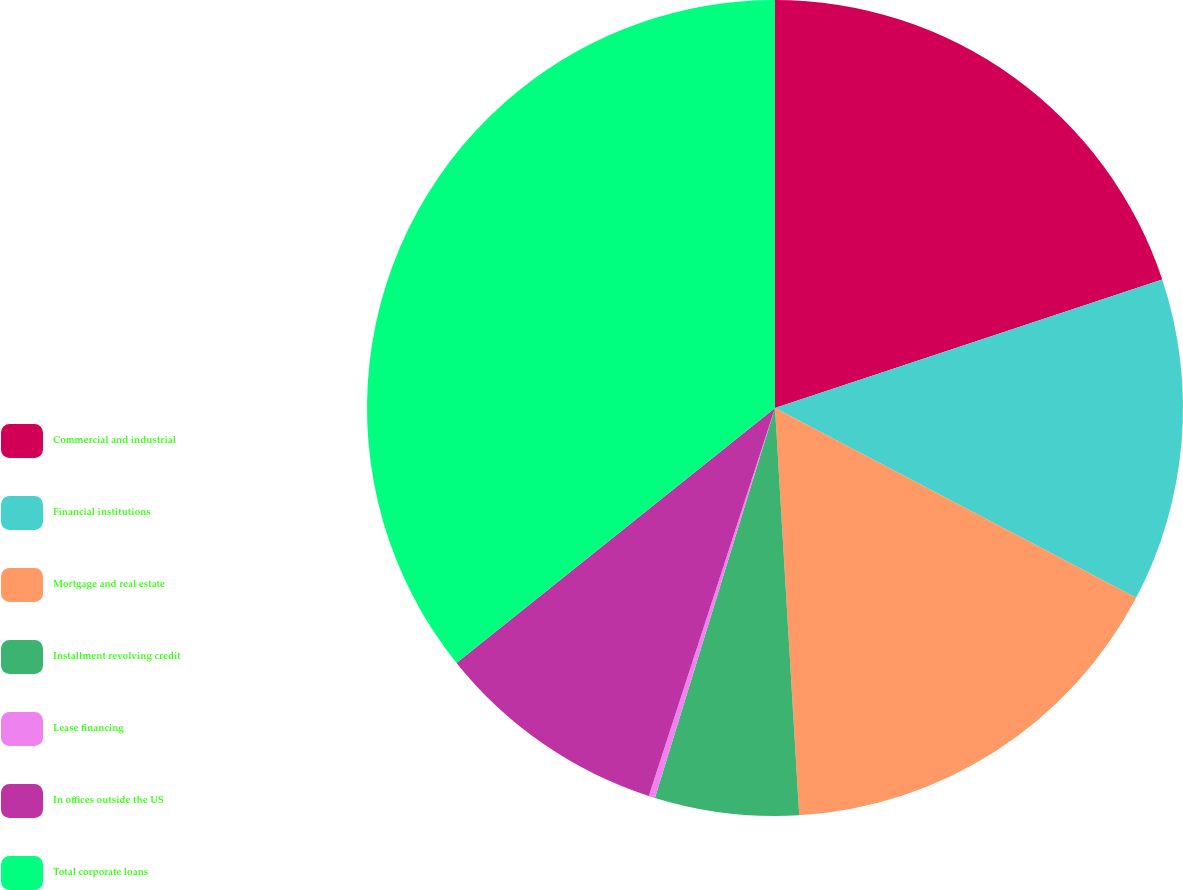Convert chart to OTSL. <chart><loc_0><loc_0><loc_500><loc_500><pie_chart><fcel>Commercial and industrial<fcel>Financial institutions<fcel>Mortgage and real estate<fcel>Installment revolving credit<fcel>Lease financing<fcel>In offices outside the US<fcel>Total corporate loans<nl><fcel>19.9%<fcel>12.8%<fcel>16.35%<fcel>5.7%<fcel>0.25%<fcel>9.25%<fcel>35.74%<nl></chart> 